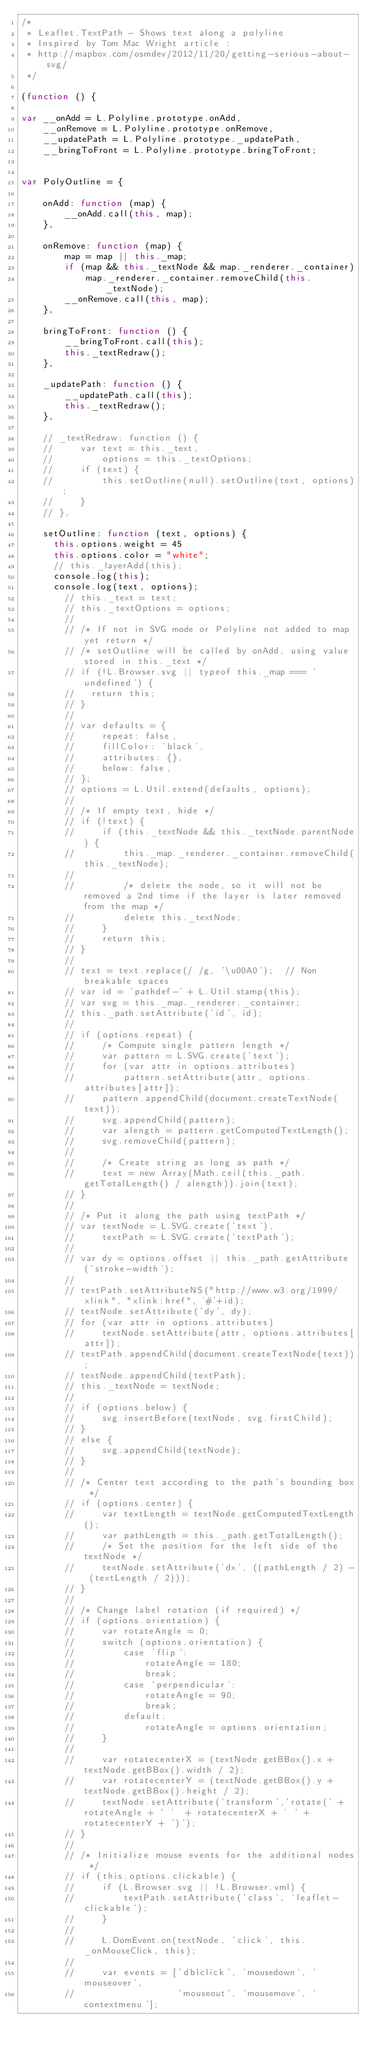Convert code to text. <code><loc_0><loc_0><loc_500><loc_500><_JavaScript_>/*
 * Leaflet.TextPath - Shows text along a polyline
 * Inspired by Tom Mac Wright article :
 * http://mapbox.com/osmdev/2012/11/20/getting-serious-about-svg/
 */

(function () {

var __onAdd = L.Polyline.prototype.onAdd,
    __onRemove = L.Polyline.prototype.onRemove,
    __updatePath = L.Polyline.prototype._updatePath,
    __bringToFront = L.Polyline.prototype.bringToFront;


var PolyOutline = {

    onAdd: function (map) {
        __onAdd.call(this, map);
    },

    onRemove: function (map) {
        map = map || this._map;
        if (map && this._textNode && map._renderer._container)
            map._renderer._container.removeChild(this._textNode);
        __onRemove.call(this, map);
    },

    bringToFront: function () {
        __bringToFront.call(this);
        this._textRedraw();
    },

    _updatePath: function () {
        __updatePath.call(this);
        this._textRedraw();
    },

    // _textRedraw: function () {
    //     var text = this._text,
    //         options = this._textOptions;
    //     if (text) {
    //         this.setOutline(null).setOutline(text, options);
    //     }
    // },

    setOutline: function (text, options) {
      this.options.weight = 45
      this.options.color = "white";
      // this._layerAdd(this);
      console.log(this);
      console.log(text, options);
        // this._text = text;
        // this._textOptions = options;
        //
        // /* If not in SVG mode or Polyline not added to map yet return */
        // /* setOutline will be called by onAdd, using value stored in this._text */
        // if (!L.Browser.svg || typeof this._map === 'undefined') {
        //   return this;
        // }
        //
        // var defaults = {
        //     repeat: false,
        //     fillColor: 'black',
        //     attributes: {},
        //     below: false,
        // };
        // options = L.Util.extend(defaults, options);
        //
        // /* If empty text, hide */
        // if (!text) {
        //     if (this._textNode && this._textNode.parentNode) {
        //         this._map._renderer._container.removeChild(this._textNode);
        //
        //         /* delete the node, so it will not be removed a 2nd time if the layer is later removed from the map */
        //         delete this._textNode;
        //     }
        //     return this;
        // }
        //
        // text = text.replace(/ /g, '\u00A0');  // Non breakable spaces
        // var id = 'pathdef-' + L.Util.stamp(this);
        // var svg = this._map._renderer._container;
        // this._path.setAttribute('id', id);
        //
        // if (options.repeat) {
        //     /* Compute single pattern length */
        //     var pattern = L.SVG.create('text');
        //     for (var attr in options.attributes)
        //         pattern.setAttribute(attr, options.attributes[attr]);
        //     pattern.appendChild(document.createTextNode(text));
        //     svg.appendChild(pattern);
        //     var alength = pattern.getComputedTextLength();
        //     svg.removeChild(pattern);
        //
        //     /* Create string as long as path */
        //     text = new Array(Math.ceil(this._path.getTotalLength() / alength)).join(text);
        // }
        //
        // /* Put it along the path using textPath */
        // var textNode = L.SVG.create('text'),
        //     textPath = L.SVG.create('textPath');
        //
        // var dy = options.offset || this._path.getAttribute('stroke-width');
        //
        // textPath.setAttributeNS("http://www.w3.org/1999/xlink", "xlink:href", '#'+id);
        // textNode.setAttribute('dy', dy);
        // for (var attr in options.attributes)
        //     textNode.setAttribute(attr, options.attributes[attr]);
        // textPath.appendChild(document.createTextNode(text));
        // textNode.appendChild(textPath);
        // this._textNode = textNode;
        //
        // if (options.below) {
        //     svg.insertBefore(textNode, svg.firstChild);
        // }
        // else {
        //     svg.appendChild(textNode);
        // }
        //
        // /* Center text according to the path's bounding box */
        // if (options.center) {
        //     var textLength = textNode.getComputedTextLength();
        //     var pathLength = this._path.getTotalLength();
        //     /* Set the position for the left side of the textNode */
        //     textNode.setAttribute('dx', ((pathLength / 2) - (textLength / 2)));
        // }
        //
        // /* Change label rotation (if required) */
        // if (options.orientation) {
        //     var rotateAngle = 0;
        //     switch (options.orientation) {
        //         case 'flip':
        //             rotateAngle = 180;
        //             break;
        //         case 'perpendicular':
        //             rotateAngle = 90;
        //             break;
        //         default:
        //             rotateAngle = options.orientation;
        //     }
        //
        //     var rotatecenterX = (textNode.getBBox().x + textNode.getBBox().width / 2);
        //     var rotatecenterY = (textNode.getBBox().y + textNode.getBBox().height / 2);
        //     textNode.setAttribute('transform','rotate(' + rotateAngle + ' '  + rotatecenterX + ' ' + rotatecenterY + ')');
        // }
        //
        // /* Initialize mouse events for the additional nodes */
        // if (this.options.clickable) {
        //     if (L.Browser.svg || !L.Browser.vml) {
        //         textPath.setAttribute('class', 'leaflet-clickable');
        //     }
        //
        //     L.DomEvent.on(textNode, 'click', this._onMouseClick, this);
        //
        //     var events = ['dblclick', 'mousedown', 'mouseover',
        //                   'mouseout', 'mousemove', 'contextmenu'];</code> 